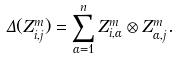<formula> <loc_0><loc_0><loc_500><loc_500>\Delta ( Z _ { i , j } ^ { m } ) = \sum _ { \alpha = 1 } ^ { n } Z _ { i , \alpha } ^ { m } \otimes Z _ { \alpha , j } ^ { m } .</formula> 